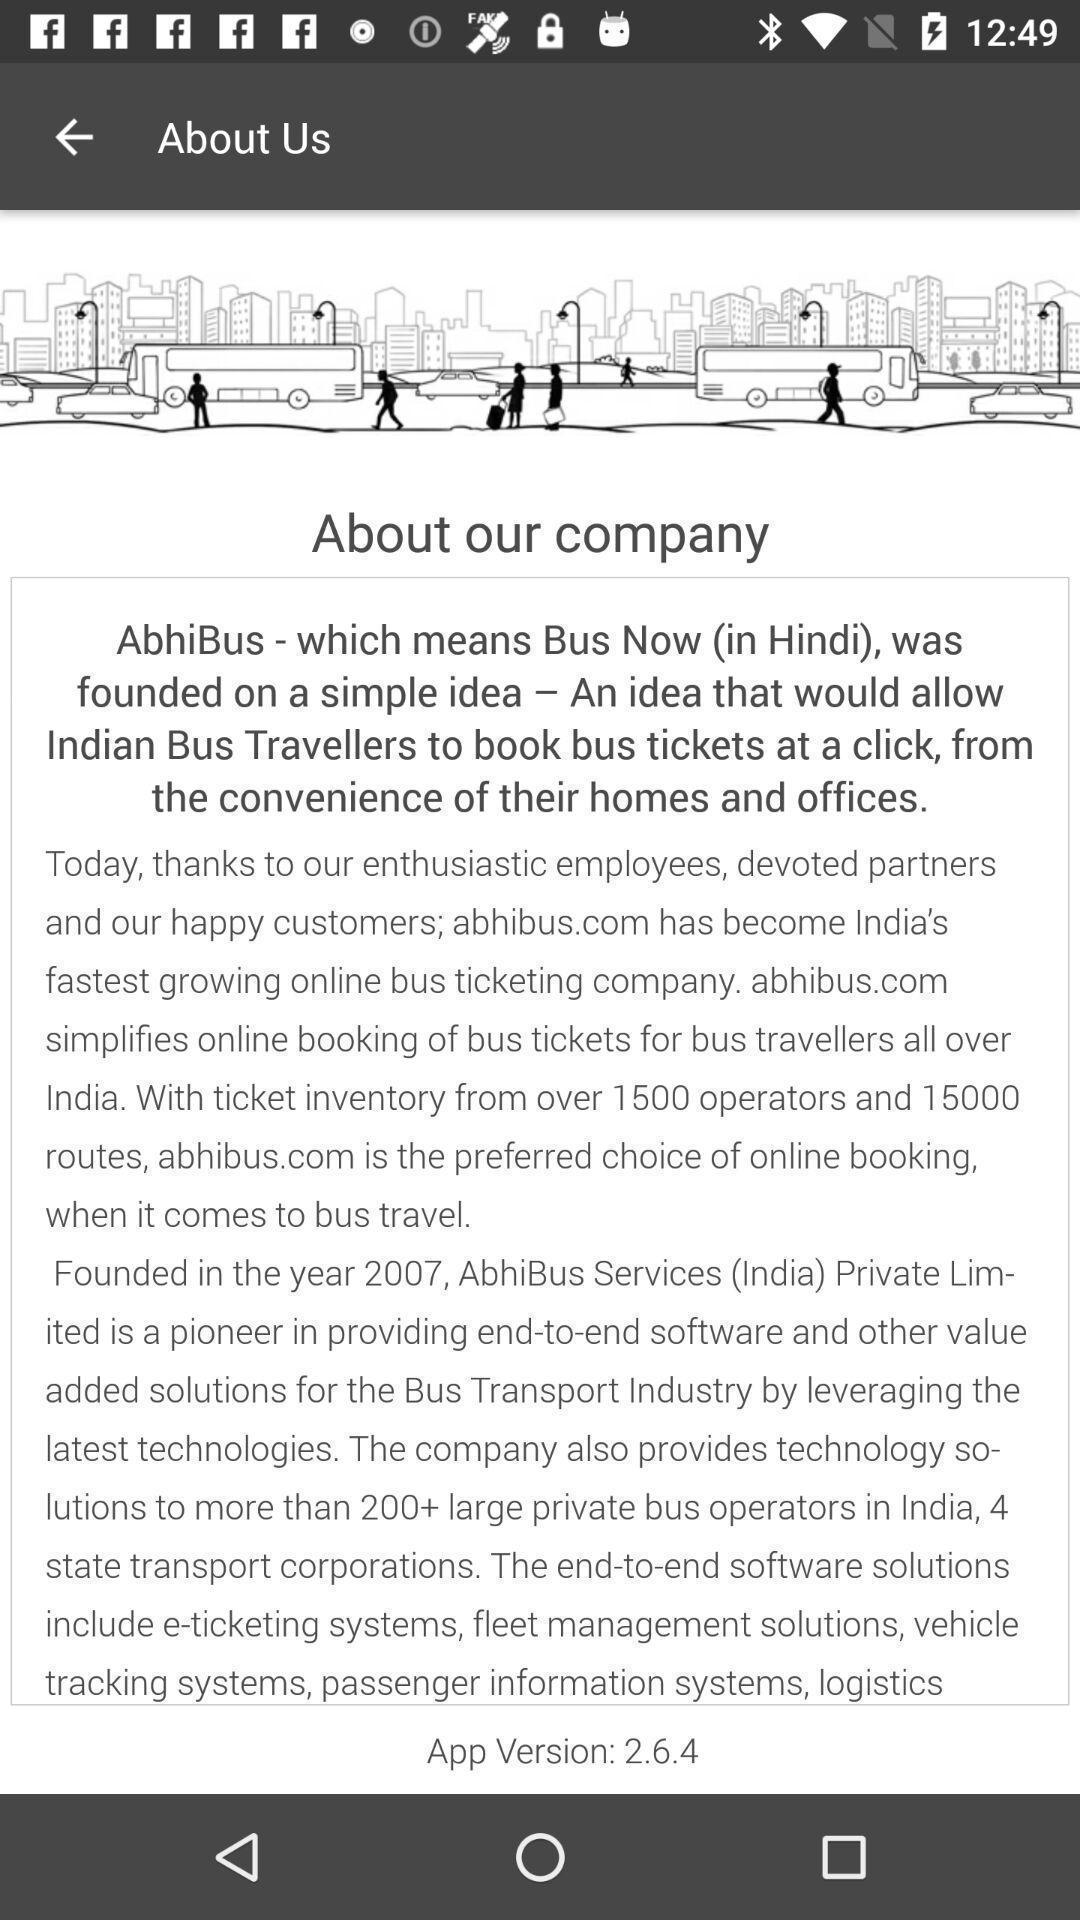Provide a textual representation of this image. Page displaying the information of the company. 